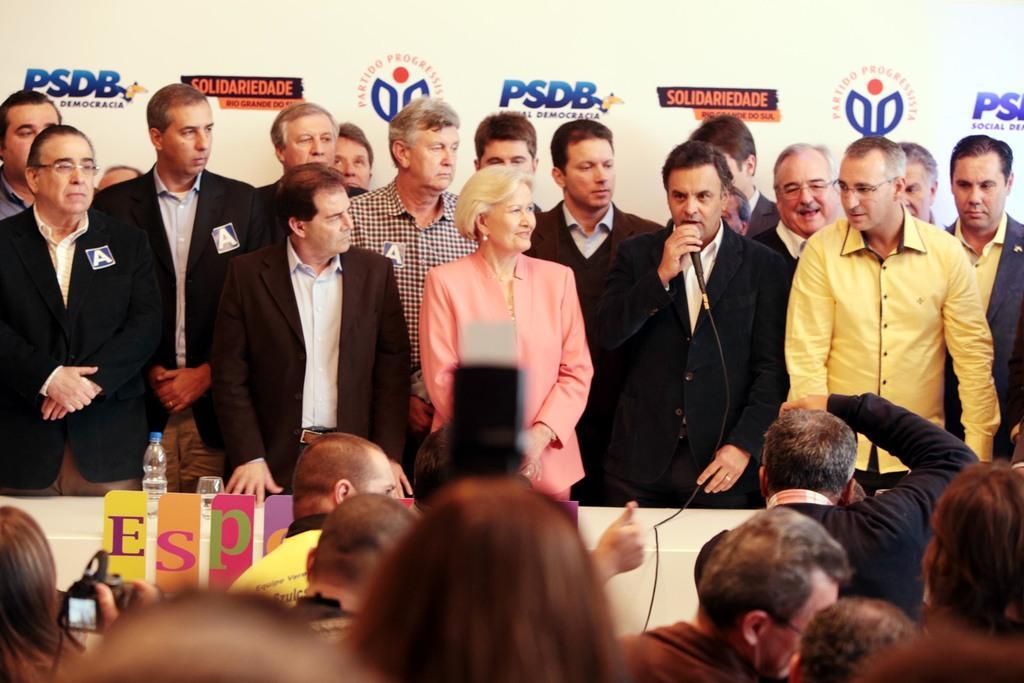Describe this image in one or two sentences. In this image I can see group of people standing and one person is holding a mic. I can see water-bottle and glass on the table. In front I can see a person holding a camera. Back Side I can see banner and something is written on it with different color. 